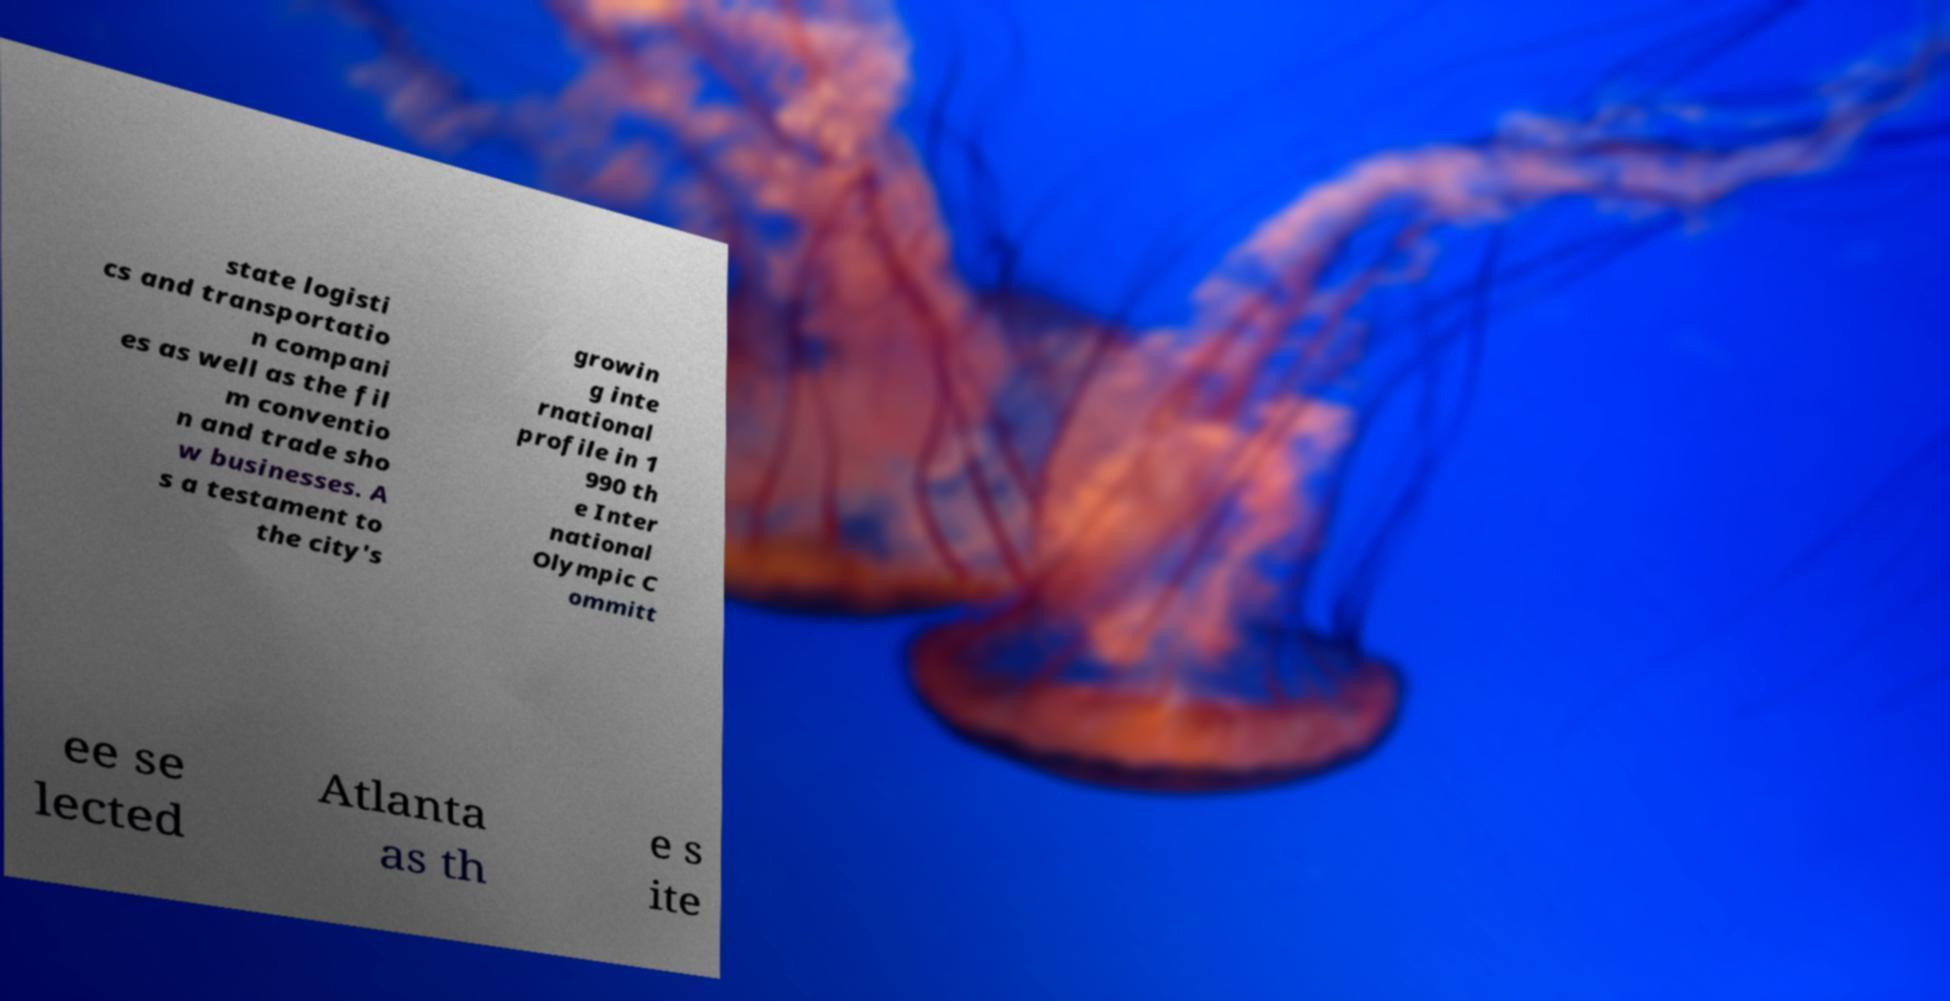For documentation purposes, I need the text within this image transcribed. Could you provide that? state logisti cs and transportatio n compani es as well as the fil m conventio n and trade sho w businesses. A s a testament to the city's growin g inte rnational profile in 1 990 th e Inter national Olympic C ommitt ee se lected Atlanta as th e s ite 